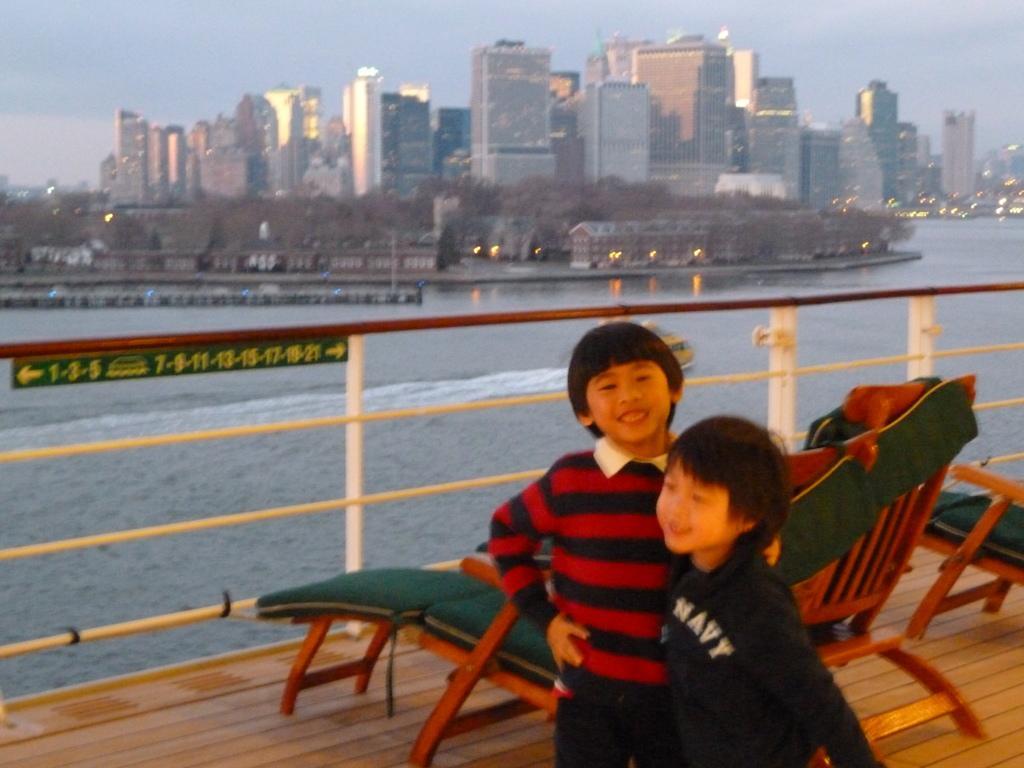Could you give a brief overview of what you see in this image? In this image, we can see 2 kids are standing. And they are smiling together. They wear a t shirts. Behind them, we can see a chairs. Here we can see wooden floor. The background, we can see water, some buildings, lights. Here there is a fencing. We can see some board here. 